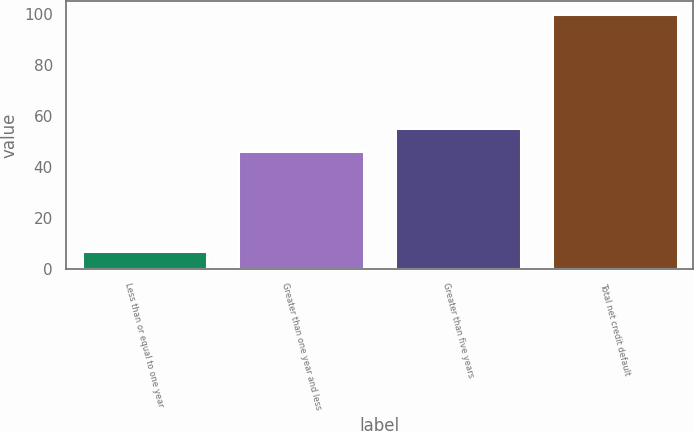Convert chart. <chart><loc_0><loc_0><loc_500><loc_500><bar_chart><fcel>Less than or equal to one year<fcel>Greater than one year and less<fcel>Greater than five years<fcel>Total net credit default<nl><fcel>7<fcel>46<fcel>55.3<fcel>100<nl></chart> 